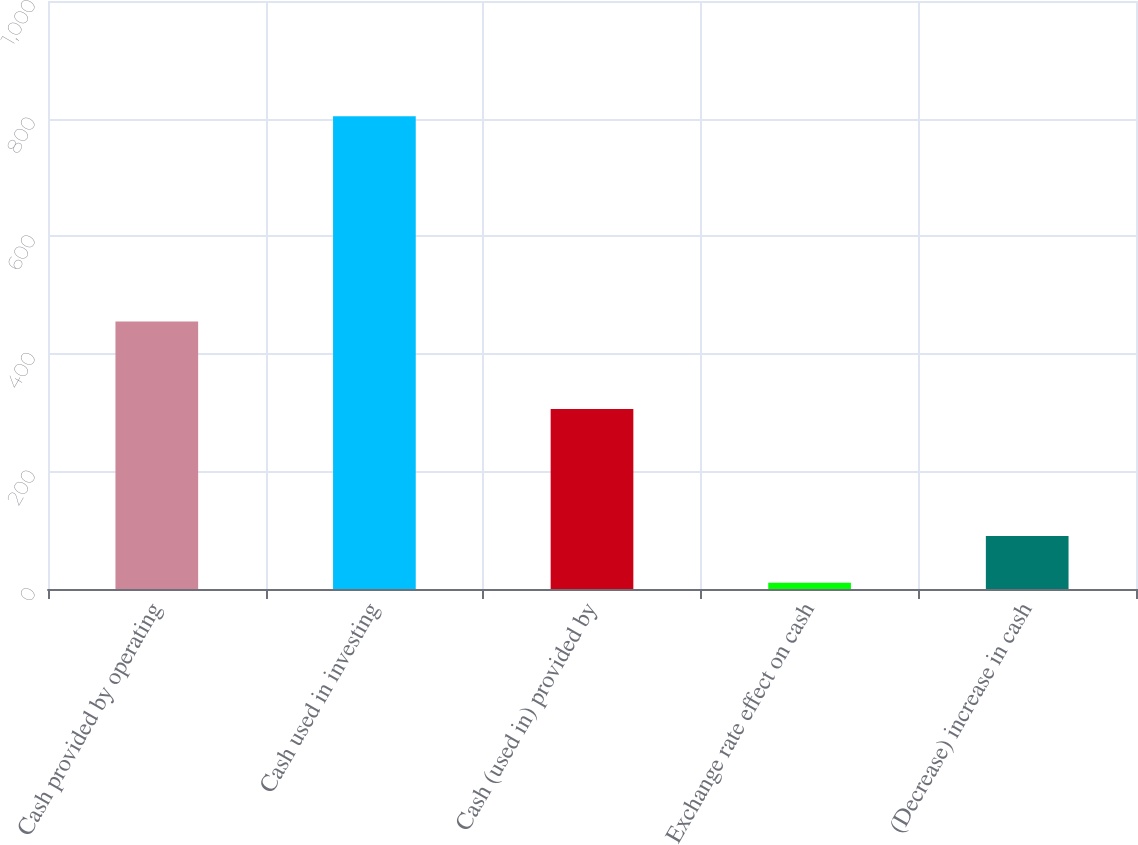Convert chart to OTSL. <chart><loc_0><loc_0><loc_500><loc_500><bar_chart><fcel>Cash provided by operating<fcel>Cash used in investing<fcel>Cash (used in) provided by<fcel>Exchange rate effect on cash<fcel>(Decrease) increase in cash<nl><fcel>454.9<fcel>804.1<fcel>306<fcel>10.6<fcel>89.95<nl></chart> 